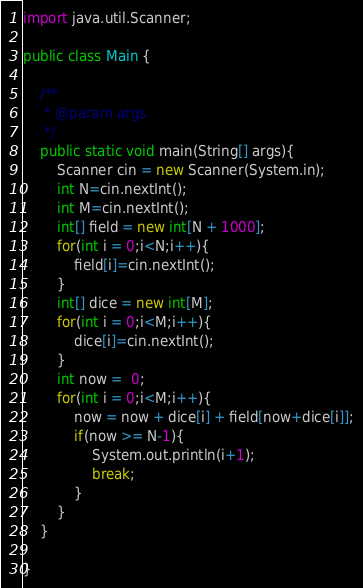Convert code to text. <code><loc_0><loc_0><loc_500><loc_500><_Java_>import java.util.Scanner;

public class Main {

	/**
	 * @param args
	 */
	public static void main(String[] args){ 
		Scanner cin = new Scanner(System.in);
		int N=cin.nextInt();
		int M=cin.nextInt();
		int[] field = new int[N + 1000];
		for(int i = 0;i<N;i++){
			field[i]=cin.nextInt();
		}
		int[] dice = new int[M];
		for(int i = 0;i<M;i++){
			dice[i]=cin.nextInt();
		}
		int now =  0;
		for(int i = 0;i<M;i++){
			now = now + dice[i] + field[now+dice[i]];
			if(now >= N-1){
				System.out.println(i+1);
				break;
			}
		}
	}

}</code> 